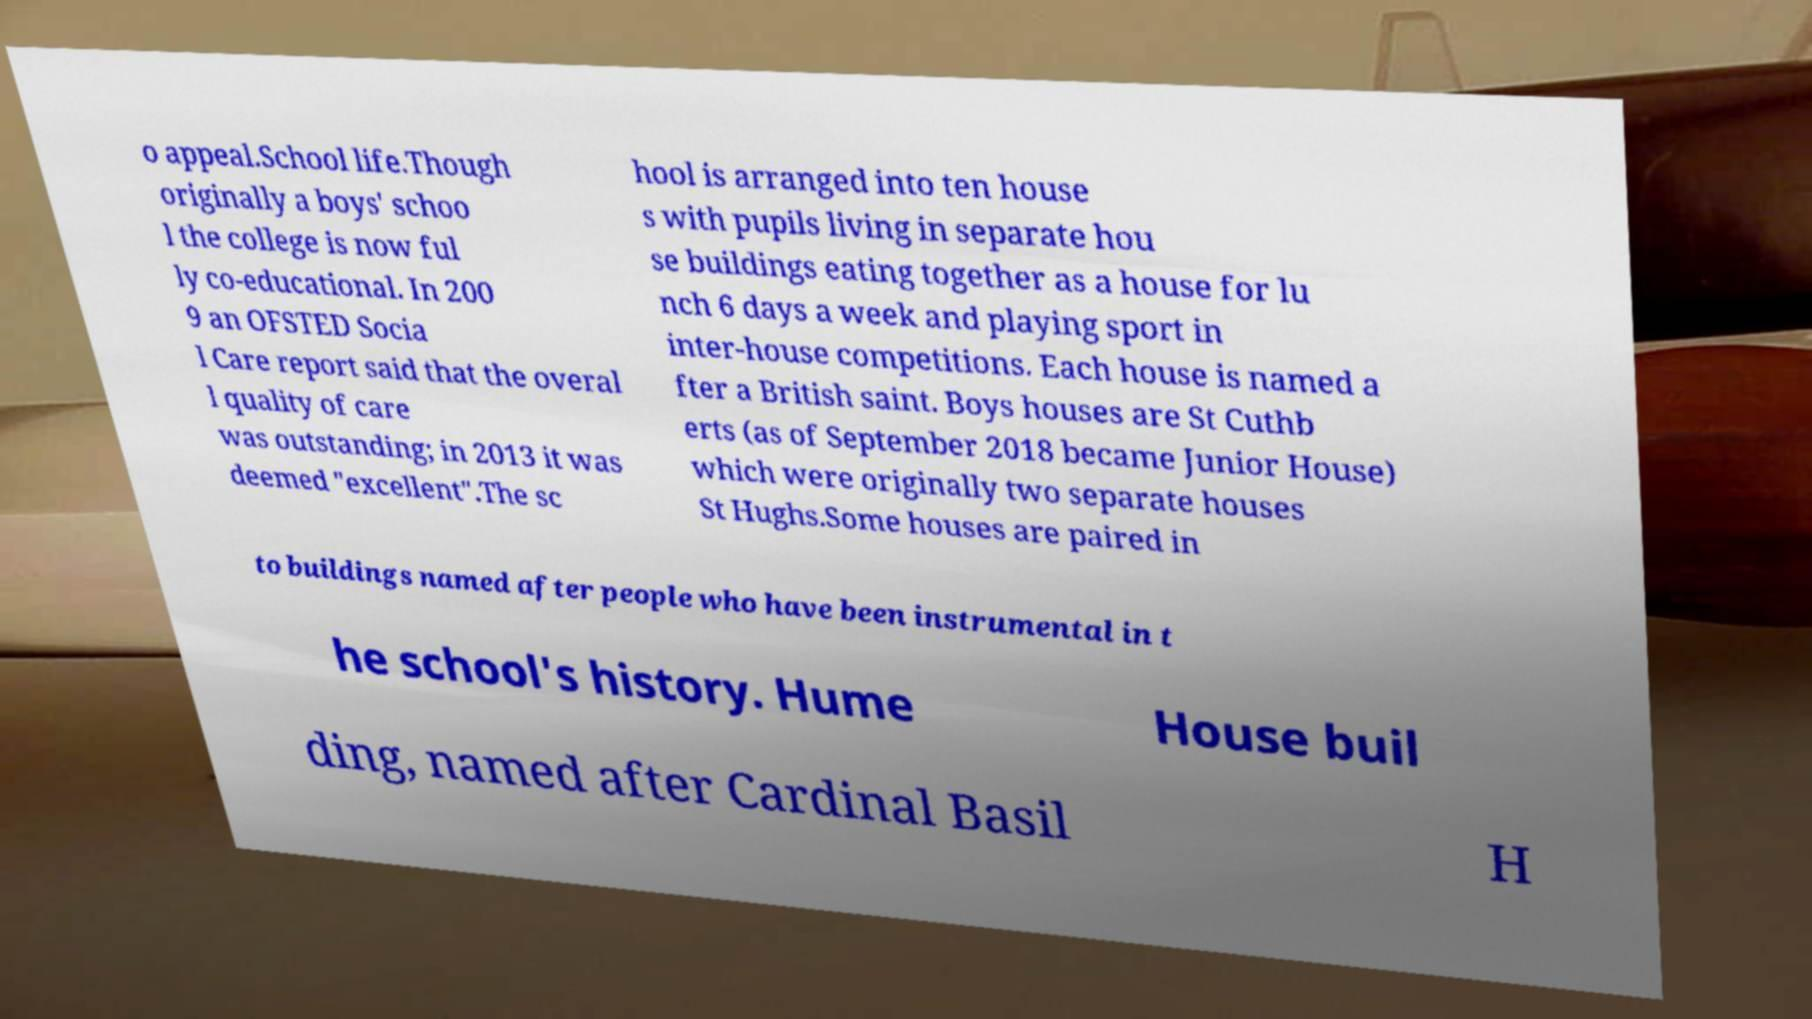Could you extract and type out the text from this image? o appeal.School life.Though originally a boys' schoo l the college is now ful ly co-educational. In 200 9 an OFSTED Socia l Care report said that the overal l quality of care was outstanding; in 2013 it was deemed "excellent".The sc hool is arranged into ten house s with pupils living in separate hou se buildings eating together as a house for lu nch 6 days a week and playing sport in inter-house competitions. Each house is named a fter a British saint. Boys houses are St Cuthb erts (as of September 2018 became Junior House) which were originally two separate houses St Hughs.Some houses are paired in to buildings named after people who have been instrumental in t he school's history. Hume House buil ding, named after Cardinal Basil H 